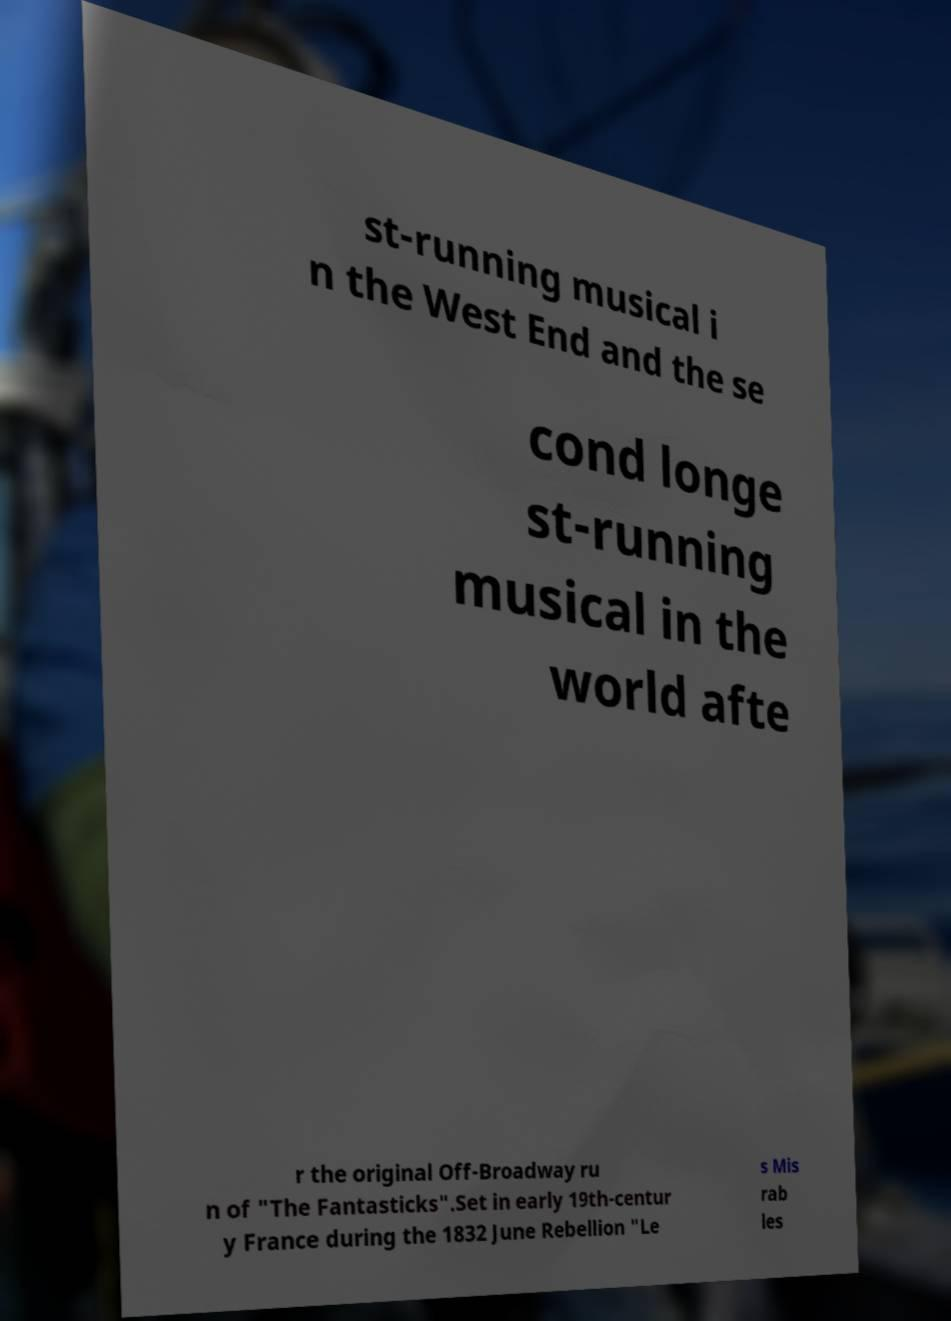I need the written content from this picture converted into text. Can you do that? st-running musical i n the West End and the se cond longe st-running musical in the world afte r the original Off-Broadway ru n of "The Fantasticks".Set in early 19th-centur y France during the 1832 June Rebellion "Le s Mis rab les 